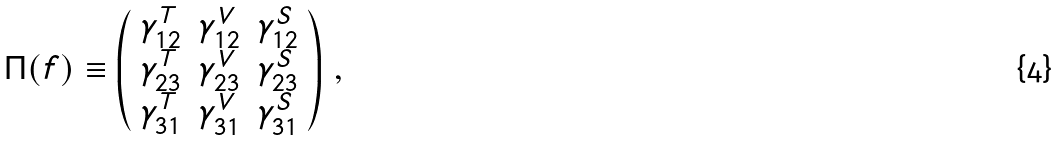<formula> <loc_0><loc_0><loc_500><loc_500>\Pi ( f ) \equiv \left ( \begin{array} { c c c } \gamma ^ { T } _ { 1 2 } & \gamma ^ { V } _ { 1 2 } & \gamma ^ { S } _ { 1 2 } \\ \gamma ^ { T } _ { 2 3 } & \gamma ^ { V } _ { 2 3 } & \gamma ^ { S } _ { 2 3 } \\ \gamma ^ { T } _ { 3 1 } & \gamma ^ { V } _ { 3 1 } & \gamma ^ { S } _ { 3 1 } \end{array} \right ) \, ,</formula> 